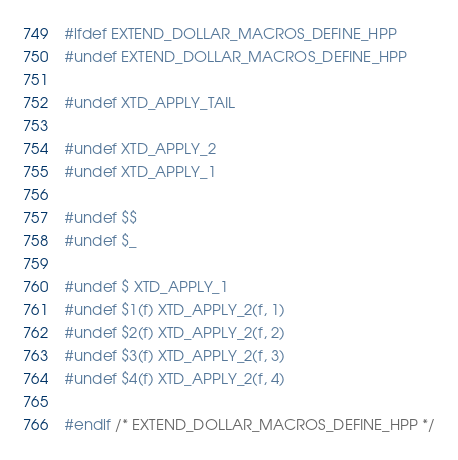<code> <loc_0><loc_0><loc_500><loc_500><_C++_>#ifdef EXTEND_DOLLAR_MACROS_DEFINE_HPP
#undef EXTEND_DOLLAR_MACROS_DEFINE_HPP

#undef XTD_APPLY_TAIL

#undef XTD_APPLY_2
#undef XTD_APPLY_1

#undef $$
#undef $_

#undef $ XTD_APPLY_1
#undef $1(f) XTD_APPLY_2(f, 1)
#undef $2(f) XTD_APPLY_2(f, 2)
#undef $3(f) XTD_APPLY_2(f, 3)
#undef $4(f) XTD_APPLY_2(f, 4)

#endif /* EXTEND_DOLLAR_MACROS_DEFINE_HPP */
</code> 